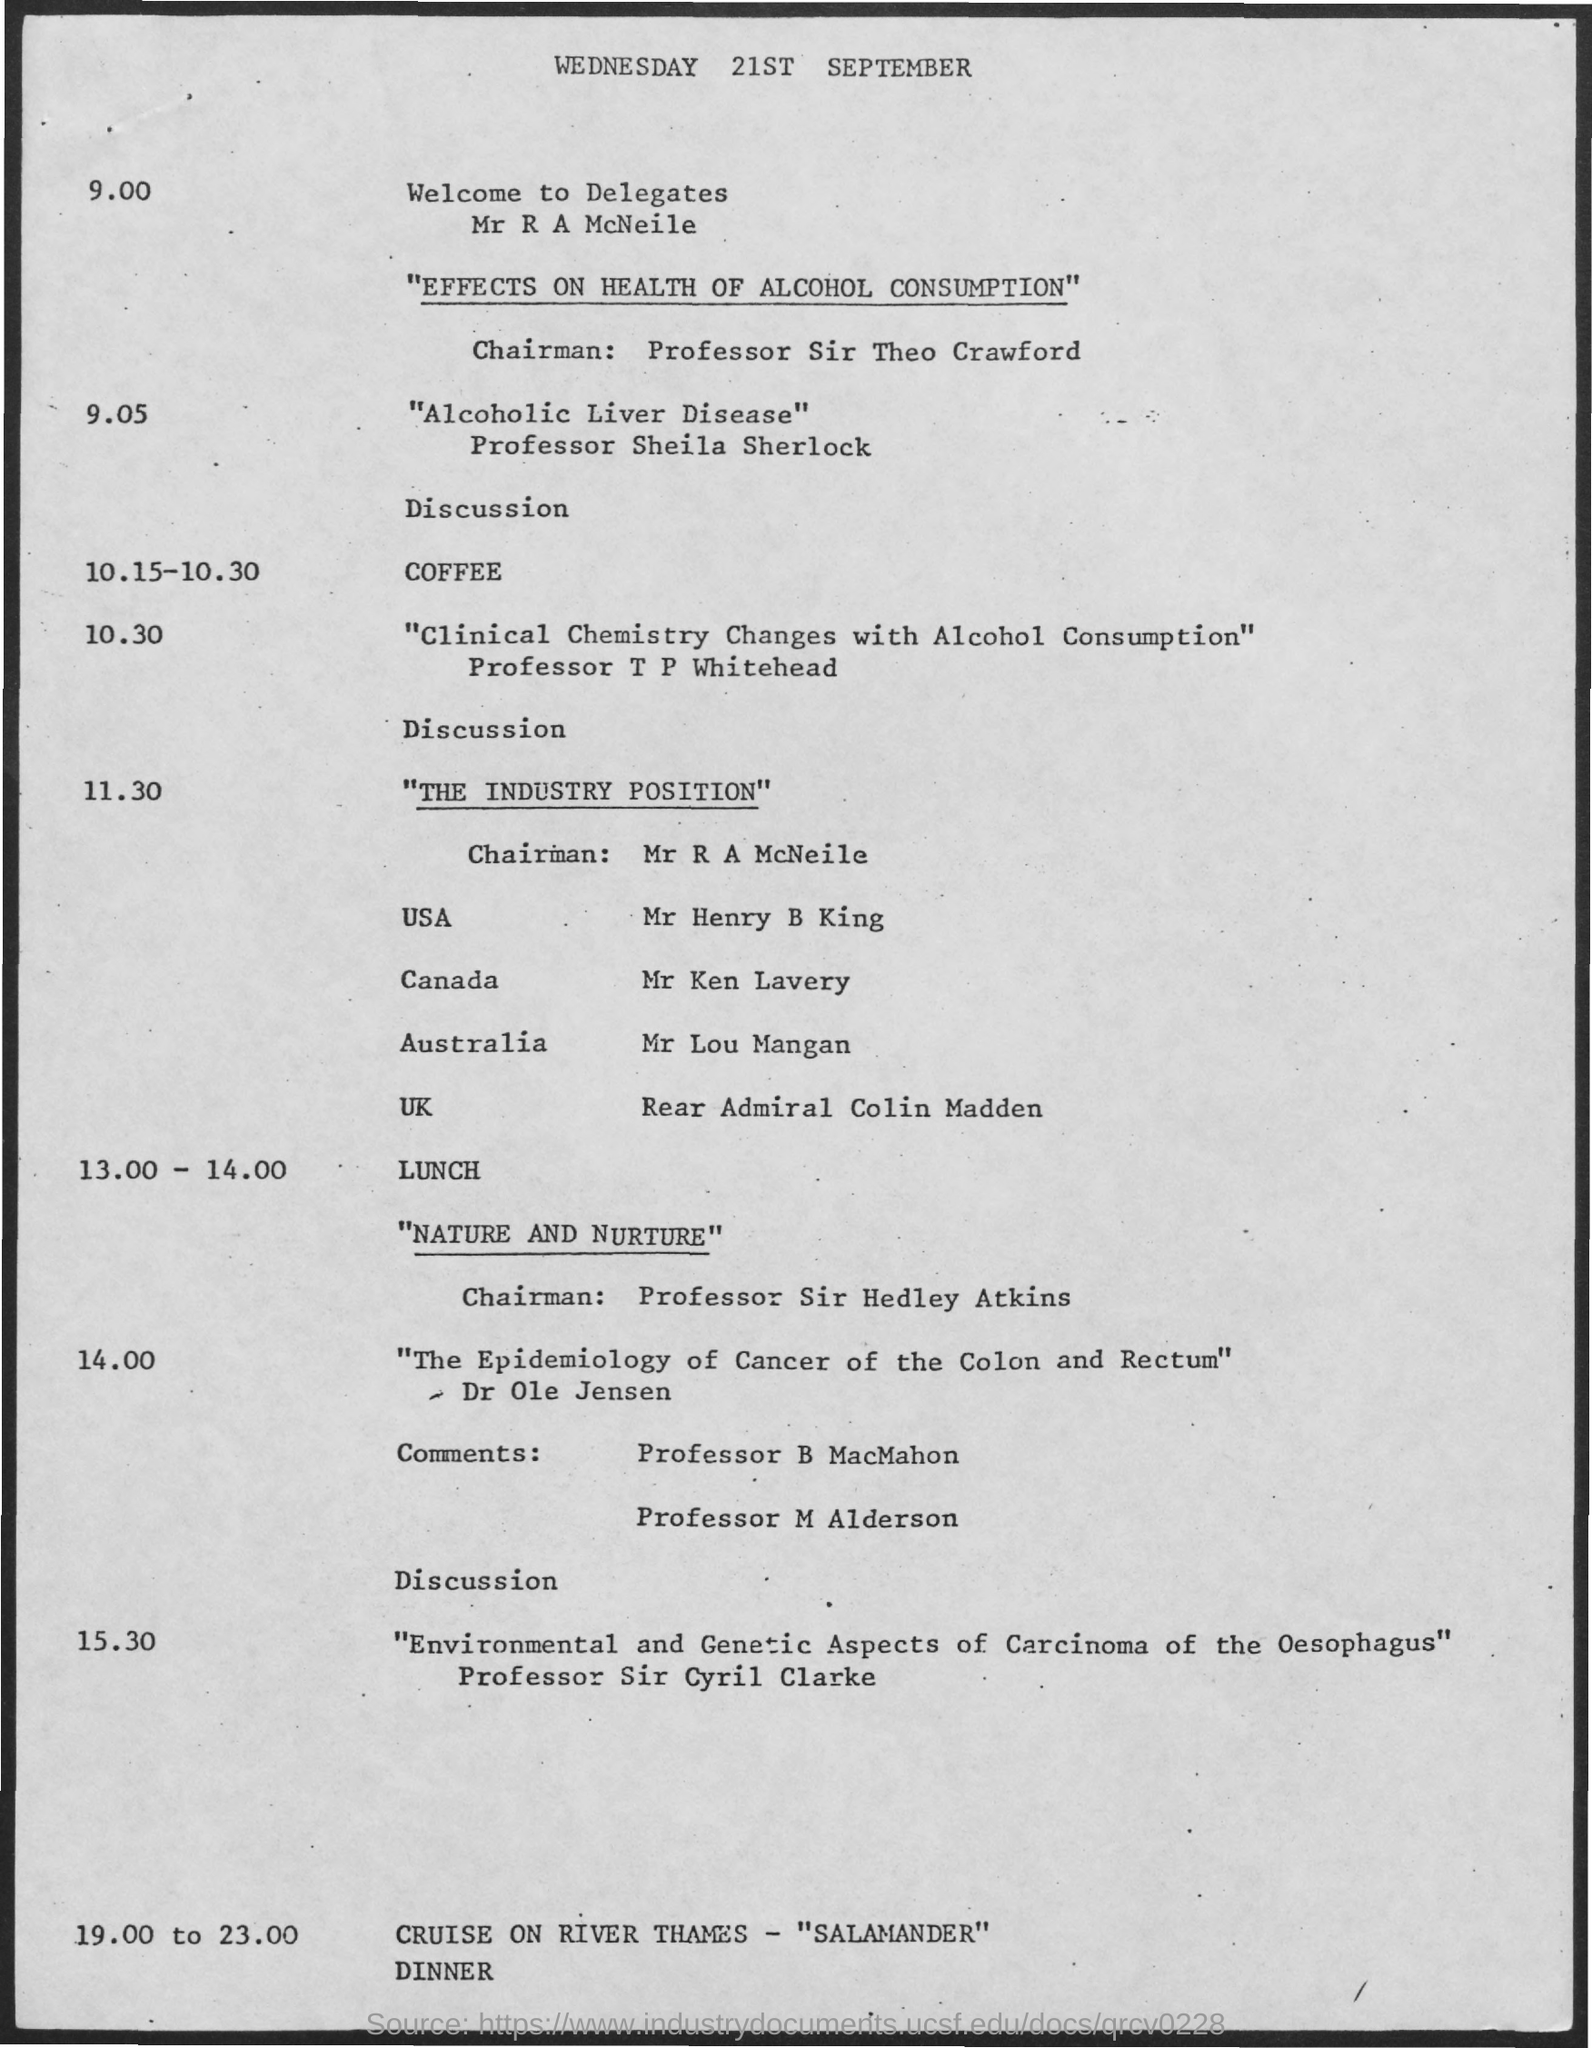Point out several critical features in this image. The document specifies that the date is Wednesday, September 21st. 